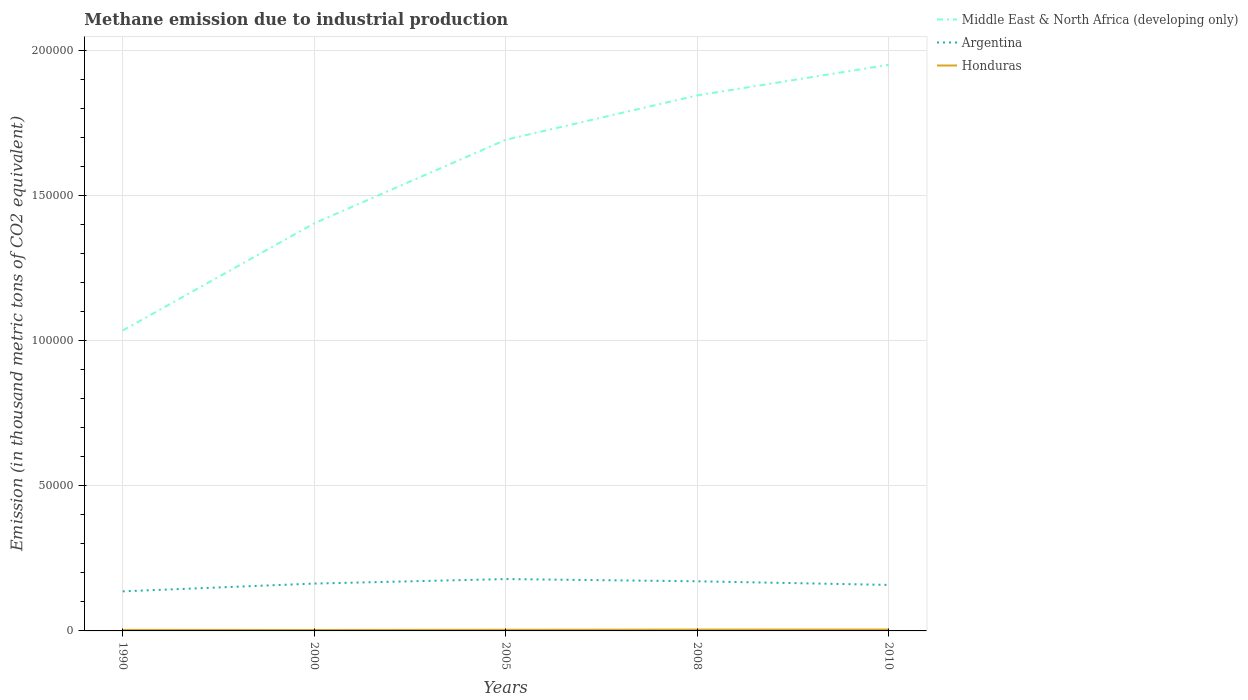Across all years, what is the maximum amount of methane emitted in Middle East & North Africa (developing only)?
Your answer should be very brief. 1.03e+05. What is the total amount of methane emitted in Honduras in the graph?
Provide a short and direct response. -84.9. What is the difference between the highest and the second highest amount of methane emitted in Middle East & North Africa (developing only)?
Offer a terse response. 9.15e+04. What is the difference between the highest and the lowest amount of methane emitted in Middle East & North Africa (developing only)?
Ensure brevity in your answer.  3. Is the amount of methane emitted in Argentina strictly greater than the amount of methane emitted in Honduras over the years?
Make the answer very short. No. What is the difference between two consecutive major ticks on the Y-axis?
Your answer should be very brief. 5.00e+04. Are the values on the major ticks of Y-axis written in scientific E-notation?
Provide a succinct answer. No. Does the graph contain any zero values?
Ensure brevity in your answer.  No. Where does the legend appear in the graph?
Keep it short and to the point. Top right. What is the title of the graph?
Your response must be concise. Methane emission due to industrial production. Does "Togo" appear as one of the legend labels in the graph?
Your answer should be very brief. No. What is the label or title of the X-axis?
Offer a terse response. Years. What is the label or title of the Y-axis?
Your response must be concise. Emission (in thousand metric tons of CO2 equivalent). What is the Emission (in thousand metric tons of CO2 equivalent) of Middle East & North Africa (developing only) in 1990?
Your answer should be compact. 1.03e+05. What is the Emission (in thousand metric tons of CO2 equivalent) of Argentina in 1990?
Provide a succinct answer. 1.36e+04. What is the Emission (in thousand metric tons of CO2 equivalent) of Honduras in 1990?
Offer a very short reply. 349.7. What is the Emission (in thousand metric tons of CO2 equivalent) in Middle East & North Africa (developing only) in 2000?
Give a very brief answer. 1.40e+05. What is the Emission (in thousand metric tons of CO2 equivalent) of Argentina in 2000?
Offer a terse response. 1.63e+04. What is the Emission (in thousand metric tons of CO2 equivalent) of Honduras in 2000?
Ensure brevity in your answer.  315.9. What is the Emission (in thousand metric tons of CO2 equivalent) of Middle East & North Africa (developing only) in 2005?
Give a very brief answer. 1.69e+05. What is the Emission (in thousand metric tons of CO2 equivalent) of Argentina in 2005?
Provide a succinct answer. 1.79e+04. What is the Emission (in thousand metric tons of CO2 equivalent) in Honduras in 2005?
Provide a succinct answer. 393.2. What is the Emission (in thousand metric tons of CO2 equivalent) of Middle East & North Africa (developing only) in 2008?
Offer a terse response. 1.84e+05. What is the Emission (in thousand metric tons of CO2 equivalent) in Argentina in 2008?
Your answer should be very brief. 1.71e+04. What is the Emission (in thousand metric tons of CO2 equivalent) in Honduras in 2008?
Ensure brevity in your answer.  461.7. What is the Emission (in thousand metric tons of CO2 equivalent) of Middle East & North Africa (developing only) in 2010?
Give a very brief answer. 1.95e+05. What is the Emission (in thousand metric tons of CO2 equivalent) of Argentina in 2010?
Make the answer very short. 1.58e+04. What is the Emission (in thousand metric tons of CO2 equivalent) in Honduras in 2010?
Your answer should be compact. 478.1. Across all years, what is the maximum Emission (in thousand metric tons of CO2 equivalent) of Middle East & North Africa (developing only)?
Give a very brief answer. 1.95e+05. Across all years, what is the maximum Emission (in thousand metric tons of CO2 equivalent) of Argentina?
Your answer should be compact. 1.79e+04. Across all years, what is the maximum Emission (in thousand metric tons of CO2 equivalent) of Honduras?
Your answer should be compact. 478.1. Across all years, what is the minimum Emission (in thousand metric tons of CO2 equivalent) of Middle East & North Africa (developing only)?
Offer a terse response. 1.03e+05. Across all years, what is the minimum Emission (in thousand metric tons of CO2 equivalent) in Argentina?
Your answer should be very brief. 1.36e+04. Across all years, what is the minimum Emission (in thousand metric tons of CO2 equivalent) of Honduras?
Your answer should be very brief. 315.9. What is the total Emission (in thousand metric tons of CO2 equivalent) of Middle East & North Africa (developing only) in the graph?
Provide a succinct answer. 7.92e+05. What is the total Emission (in thousand metric tons of CO2 equivalent) of Argentina in the graph?
Ensure brevity in your answer.  8.07e+04. What is the total Emission (in thousand metric tons of CO2 equivalent) of Honduras in the graph?
Your answer should be very brief. 1998.6. What is the difference between the Emission (in thousand metric tons of CO2 equivalent) in Middle East & North Africa (developing only) in 1990 and that in 2000?
Provide a succinct answer. -3.69e+04. What is the difference between the Emission (in thousand metric tons of CO2 equivalent) of Argentina in 1990 and that in 2000?
Give a very brief answer. -2677.8. What is the difference between the Emission (in thousand metric tons of CO2 equivalent) of Honduras in 1990 and that in 2000?
Keep it short and to the point. 33.8. What is the difference between the Emission (in thousand metric tons of CO2 equivalent) of Middle East & North Africa (developing only) in 1990 and that in 2005?
Your answer should be very brief. -6.57e+04. What is the difference between the Emission (in thousand metric tons of CO2 equivalent) in Argentina in 1990 and that in 2005?
Offer a very short reply. -4226.1. What is the difference between the Emission (in thousand metric tons of CO2 equivalent) in Honduras in 1990 and that in 2005?
Offer a very short reply. -43.5. What is the difference between the Emission (in thousand metric tons of CO2 equivalent) in Middle East & North Africa (developing only) in 1990 and that in 2008?
Ensure brevity in your answer.  -8.10e+04. What is the difference between the Emission (in thousand metric tons of CO2 equivalent) in Argentina in 1990 and that in 2008?
Offer a very short reply. -3465. What is the difference between the Emission (in thousand metric tons of CO2 equivalent) of Honduras in 1990 and that in 2008?
Ensure brevity in your answer.  -112. What is the difference between the Emission (in thousand metric tons of CO2 equivalent) of Middle East & North Africa (developing only) in 1990 and that in 2010?
Give a very brief answer. -9.15e+04. What is the difference between the Emission (in thousand metric tons of CO2 equivalent) in Argentina in 1990 and that in 2010?
Your response must be concise. -2215.6. What is the difference between the Emission (in thousand metric tons of CO2 equivalent) in Honduras in 1990 and that in 2010?
Give a very brief answer. -128.4. What is the difference between the Emission (in thousand metric tons of CO2 equivalent) of Middle East & North Africa (developing only) in 2000 and that in 2005?
Your answer should be very brief. -2.88e+04. What is the difference between the Emission (in thousand metric tons of CO2 equivalent) of Argentina in 2000 and that in 2005?
Ensure brevity in your answer.  -1548.3. What is the difference between the Emission (in thousand metric tons of CO2 equivalent) in Honduras in 2000 and that in 2005?
Your response must be concise. -77.3. What is the difference between the Emission (in thousand metric tons of CO2 equivalent) of Middle East & North Africa (developing only) in 2000 and that in 2008?
Your response must be concise. -4.41e+04. What is the difference between the Emission (in thousand metric tons of CO2 equivalent) of Argentina in 2000 and that in 2008?
Your answer should be very brief. -787.2. What is the difference between the Emission (in thousand metric tons of CO2 equivalent) in Honduras in 2000 and that in 2008?
Give a very brief answer. -145.8. What is the difference between the Emission (in thousand metric tons of CO2 equivalent) of Middle East & North Africa (developing only) in 2000 and that in 2010?
Provide a succinct answer. -5.46e+04. What is the difference between the Emission (in thousand metric tons of CO2 equivalent) in Argentina in 2000 and that in 2010?
Keep it short and to the point. 462.2. What is the difference between the Emission (in thousand metric tons of CO2 equivalent) in Honduras in 2000 and that in 2010?
Keep it short and to the point. -162.2. What is the difference between the Emission (in thousand metric tons of CO2 equivalent) of Middle East & North Africa (developing only) in 2005 and that in 2008?
Provide a short and direct response. -1.53e+04. What is the difference between the Emission (in thousand metric tons of CO2 equivalent) of Argentina in 2005 and that in 2008?
Your answer should be compact. 761.1. What is the difference between the Emission (in thousand metric tons of CO2 equivalent) in Honduras in 2005 and that in 2008?
Give a very brief answer. -68.5. What is the difference between the Emission (in thousand metric tons of CO2 equivalent) in Middle East & North Africa (developing only) in 2005 and that in 2010?
Give a very brief answer. -2.58e+04. What is the difference between the Emission (in thousand metric tons of CO2 equivalent) of Argentina in 2005 and that in 2010?
Your answer should be very brief. 2010.5. What is the difference between the Emission (in thousand metric tons of CO2 equivalent) of Honduras in 2005 and that in 2010?
Provide a short and direct response. -84.9. What is the difference between the Emission (in thousand metric tons of CO2 equivalent) of Middle East & North Africa (developing only) in 2008 and that in 2010?
Offer a terse response. -1.05e+04. What is the difference between the Emission (in thousand metric tons of CO2 equivalent) of Argentina in 2008 and that in 2010?
Provide a short and direct response. 1249.4. What is the difference between the Emission (in thousand metric tons of CO2 equivalent) of Honduras in 2008 and that in 2010?
Make the answer very short. -16.4. What is the difference between the Emission (in thousand metric tons of CO2 equivalent) of Middle East & North Africa (developing only) in 1990 and the Emission (in thousand metric tons of CO2 equivalent) of Argentina in 2000?
Offer a very short reply. 8.71e+04. What is the difference between the Emission (in thousand metric tons of CO2 equivalent) of Middle East & North Africa (developing only) in 1990 and the Emission (in thousand metric tons of CO2 equivalent) of Honduras in 2000?
Give a very brief answer. 1.03e+05. What is the difference between the Emission (in thousand metric tons of CO2 equivalent) of Argentina in 1990 and the Emission (in thousand metric tons of CO2 equivalent) of Honduras in 2000?
Ensure brevity in your answer.  1.33e+04. What is the difference between the Emission (in thousand metric tons of CO2 equivalent) of Middle East & North Africa (developing only) in 1990 and the Emission (in thousand metric tons of CO2 equivalent) of Argentina in 2005?
Provide a succinct answer. 8.56e+04. What is the difference between the Emission (in thousand metric tons of CO2 equivalent) in Middle East & North Africa (developing only) in 1990 and the Emission (in thousand metric tons of CO2 equivalent) in Honduras in 2005?
Ensure brevity in your answer.  1.03e+05. What is the difference between the Emission (in thousand metric tons of CO2 equivalent) in Argentina in 1990 and the Emission (in thousand metric tons of CO2 equivalent) in Honduras in 2005?
Your answer should be very brief. 1.32e+04. What is the difference between the Emission (in thousand metric tons of CO2 equivalent) of Middle East & North Africa (developing only) in 1990 and the Emission (in thousand metric tons of CO2 equivalent) of Argentina in 2008?
Provide a short and direct response. 8.63e+04. What is the difference between the Emission (in thousand metric tons of CO2 equivalent) of Middle East & North Africa (developing only) in 1990 and the Emission (in thousand metric tons of CO2 equivalent) of Honduras in 2008?
Provide a succinct answer. 1.03e+05. What is the difference between the Emission (in thousand metric tons of CO2 equivalent) in Argentina in 1990 and the Emission (in thousand metric tons of CO2 equivalent) in Honduras in 2008?
Provide a succinct answer. 1.32e+04. What is the difference between the Emission (in thousand metric tons of CO2 equivalent) of Middle East & North Africa (developing only) in 1990 and the Emission (in thousand metric tons of CO2 equivalent) of Argentina in 2010?
Your answer should be compact. 8.76e+04. What is the difference between the Emission (in thousand metric tons of CO2 equivalent) in Middle East & North Africa (developing only) in 1990 and the Emission (in thousand metric tons of CO2 equivalent) in Honduras in 2010?
Your response must be concise. 1.03e+05. What is the difference between the Emission (in thousand metric tons of CO2 equivalent) in Argentina in 1990 and the Emission (in thousand metric tons of CO2 equivalent) in Honduras in 2010?
Offer a very short reply. 1.31e+04. What is the difference between the Emission (in thousand metric tons of CO2 equivalent) in Middle East & North Africa (developing only) in 2000 and the Emission (in thousand metric tons of CO2 equivalent) in Argentina in 2005?
Your answer should be very brief. 1.22e+05. What is the difference between the Emission (in thousand metric tons of CO2 equivalent) of Middle East & North Africa (developing only) in 2000 and the Emission (in thousand metric tons of CO2 equivalent) of Honduras in 2005?
Give a very brief answer. 1.40e+05. What is the difference between the Emission (in thousand metric tons of CO2 equivalent) of Argentina in 2000 and the Emission (in thousand metric tons of CO2 equivalent) of Honduras in 2005?
Give a very brief answer. 1.59e+04. What is the difference between the Emission (in thousand metric tons of CO2 equivalent) of Middle East & North Africa (developing only) in 2000 and the Emission (in thousand metric tons of CO2 equivalent) of Argentina in 2008?
Your answer should be very brief. 1.23e+05. What is the difference between the Emission (in thousand metric tons of CO2 equivalent) in Middle East & North Africa (developing only) in 2000 and the Emission (in thousand metric tons of CO2 equivalent) in Honduras in 2008?
Ensure brevity in your answer.  1.40e+05. What is the difference between the Emission (in thousand metric tons of CO2 equivalent) of Argentina in 2000 and the Emission (in thousand metric tons of CO2 equivalent) of Honduras in 2008?
Ensure brevity in your answer.  1.58e+04. What is the difference between the Emission (in thousand metric tons of CO2 equivalent) of Middle East & North Africa (developing only) in 2000 and the Emission (in thousand metric tons of CO2 equivalent) of Argentina in 2010?
Keep it short and to the point. 1.24e+05. What is the difference between the Emission (in thousand metric tons of CO2 equivalent) in Middle East & North Africa (developing only) in 2000 and the Emission (in thousand metric tons of CO2 equivalent) in Honduras in 2010?
Give a very brief answer. 1.40e+05. What is the difference between the Emission (in thousand metric tons of CO2 equivalent) in Argentina in 2000 and the Emission (in thousand metric tons of CO2 equivalent) in Honduras in 2010?
Your answer should be compact. 1.58e+04. What is the difference between the Emission (in thousand metric tons of CO2 equivalent) in Middle East & North Africa (developing only) in 2005 and the Emission (in thousand metric tons of CO2 equivalent) in Argentina in 2008?
Your answer should be compact. 1.52e+05. What is the difference between the Emission (in thousand metric tons of CO2 equivalent) in Middle East & North Africa (developing only) in 2005 and the Emission (in thousand metric tons of CO2 equivalent) in Honduras in 2008?
Your answer should be very brief. 1.69e+05. What is the difference between the Emission (in thousand metric tons of CO2 equivalent) in Argentina in 2005 and the Emission (in thousand metric tons of CO2 equivalent) in Honduras in 2008?
Give a very brief answer. 1.74e+04. What is the difference between the Emission (in thousand metric tons of CO2 equivalent) in Middle East & North Africa (developing only) in 2005 and the Emission (in thousand metric tons of CO2 equivalent) in Argentina in 2010?
Offer a very short reply. 1.53e+05. What is the difference between the Emission (in thousand metric tons of CO2 equivalent) of Middle East & North Africa (developing only) in 2005 and the Emission (in thousand metric tons of CO2 equivalent) of Honduras in 2010?
Your answer should be compact. 1.69e+05. What is the difference between the Emission (in thousand metric tons of CO2 equivalent) in Argentina in 2005 and the Emission (in thousand metric tons of CO2 equivalent) in Honduras in 2010?
Keep it short and to the point. 1.74e+04. What is the difference between the Emission (in thousand metric tons of CO2 equivalent) of Middle East & North Africa (developing only) in 2008 and the Emission (in thousand metric tons of CO2 equivalent) of Argentina in 2010?
Your answer should be very brief. 1.69e+05. What is the difference between the Emission (in thousand metric tons of CO2 equivalent) of Middle East & North Africa (developing only) in 2008 and the Emission (in thousand metric tons of CO2 equivalent) of Honduras in 2010?
Offer a very short reply. 1.84e+05. What is the difference between the Emission (in thousand metric tons of CO2 equivalent) of Argentina in 2008 and the Emission (in thousand metric tons of CO2 equivalent) of Honduras in 2010?
Provide a succinct answer. 1.66e+04. What is the average Emission (in thousand metric tons of CO2 equivalent) in Middle East & North Africa (developing only) per year?
Your answer should be very brief. 1.58e+05. What is the average Emission (in thousand metric tons of CO2 equivalent) in Argentina per year?
Give a very brief answer. 1.61e+04. What is the average Emission (in thousand metric tons of CO2 equivalent) of Honduras per year?
Offer a terse response. 399.72. In the year 1990, what is the difference between the Emission (in thousand metric tons of CO2 equivalent) of Middle East & North Africa (developing only) and Emission (in thousand metric tons of CO2 equivalent) of Argentina?
Provide a short and direct response. 8.98e+04. In the year 1990, what is the difference between the Emission (in thousand metric tons of CO2 equivalent) of Middle East & North Africa (developing only) and Emission (in thousand metric tons of CO2 equivalent) of Honduras?
Your response must be concise. 1.03e+05. In the year 1990, what is the difference between the Emission (in thousand metric tons of CO2 equivalent) of Argentina and Emission (in thousand metric tons of CO2 equivalent) of Honduras?
Ensure brevity in your answer.  1.33e+04. In the year 2000, what is the difference between the Emission (in thousand metric tons of CO2 equivalent) in Middle East & North Africa (developing only) and Emission (in thousand metric tons of CO2 equivalent) in Argentina?
Give a very brief answer. 1.24e+05. In the year 2000, what is the difference between the Emission (in thousand metric tons of CO2 equivalent) in Middle East & North Africa (developing only) and Emission (in thousand metric tons of CO2 equivalent) in Honduras?
Keep it short and to the point. 1.40e+05. In the year 2000, what is the difference between the Emission (in thousand metric tons of CO2 equivalent) of Argentina and Emission (in thousand metric tons of CO2 equivalent) of Honduras?
Your answer should be very brief. 1.60e+04. In the year 2005, what is the difference between the Emission (in thousand metric tons of CO2 equivalent) of Middle East & North Africa (developing only) and Emission (in thousand metric tons of CO2 equivalent) of Argentina?
Offer a terse response. 1.51e+05. In the year 2005, what is the difference between the Emission (in thousand metric tons of CO2 equivalent) in Middle East & North Africa (developing only) and Emission (in thousand metric tons of CO2 equivalent) in Honduras?
Your response must be concise. 1.69e+05. In the year 2005, what is the difference between the Emission (in thousand metric tons of CO2 equivalent) of Argentina and Emission (in thousand metric tons of CO2 equivalent) of Honduras?
Ensure brevity in your answer.  1.75e+04. In the year 2008, what is the difference between the Emission (in thousand metric tons of CO2 equivalent) of Middle East & North Africa (developing only) and Emission (in thousand metric tons of CO2 equivalent) of Argentina?
Your answer should be very brief. 1.67e+05. In the year 2008, what is the difference between the Emission (in thousand metric tons of CO2 equivalent) of Middle East & North Africa (developing only) and Emission (in thousand metric tons of CO2 equivalent) of Honduras?
Your answer should be compact. 1.84e+05. In the year 2008, what is the difference between the Emission (in thousand metric tons of CO2 equivalent) in Argentina and Emission (in thousand metric tons of CO2 equivalent) in Honduras?
Keep it short and to the point. 1.66e+04. In the year 2010, what is the difference between the Emission (in thousand metric tons of CO2 equivalent) in Middle East & North Africa (developing only) and Emission (in thousand metric tons of CO2 equivalent) in Argentina?
Keep it short and to the point. 1.79e+05. In the year 2010, what is the difference between the Emission (in thousand metric tons of CO2 equivalent) in Middle East & North Africa (developing only) and Emission (in thousand metric tons of CO2 equivalent) in Honduras?
Keep it short and to the point. 1.94e+05. In the year 2010, what is the difference between the Emission (in thousand metric tons of CO2 equivalent) in Argentina and Emission (in thousand metric tons of CO2 equivalent) in Honduras?
Your response must be concise. 1.54e+04. What is the ratio of the Emission (in thousand metric tons of CO2 equivalent) in Middle East & North Africa (developing only) in 1990 to that in 2000?
Offer a terse response. 0.74. What is the ratio of the Emission (in thousand metric tons of CO2 equivalent) in Argentina in 1990 to that in 2000?
Ensure brevity in your answer.  0.84. What is the ratio of the Emission (in thousand metric tons of CO2 equivalent) of Honduras in 1990 to that in 2000?
Offer a very short reply. 1.11. What is the ratio of the Emission (in thousand metric tons of CO2 equivalent) in Middle East & North Africa (developing only) in 1990 to that in 2005?
Keep it short and to the point. 0.61. What is the ratio of the Emission (in thousand metric tons of CO2 equivalent) of Argentina in 1990 to that in 2005?
Make the answer very short. 0.76. What is the ratio of the Emission (in thousand metric tons of CO2 equivalent) in Honduras in 1990 to that in 2005?
Your response must be concise. 0.89. What is the ratio of the Emission (in thousand metric tons of CO2 equivalent) of Middle East & North Africa (developing only) in 1990 to that in 2008?
Provide a short and direct response. 0.56. What is the ratio of the Emission (in thousand metric tons of CO2 equivalent) of Argentina in 1990 to that in 2008?
Give a very brief answer. 0.8. What is the ratio of the Emission (in thousand metric tons of CO2 equivalent) of Honduras in 1990 to that in 2008?
Your response must be concise. 0.76. What is the ratio of the Emission (in thousand metric tons of CO2 equivalent) of Middle East & North Africa (developing only) in 1990 to that in 2010?
Your response must be concise. 0.53. What is the ratio of the Emission (in thousand metric tons of CO2 equivalent) of Argentina in 1990 to that in 2010?
Offer a very short reply. 0.86. What is the ratio of the Emission (in thousand metric tons of CO2 equivalent) of Honduras in 1990 to that in 2010?
Your answer should be compact. 0.73. What is the ratio of the Emission (in thousand metric tons of CO2 equivalent) of Middle East & North Africa (developing only) in 2000 to that in 2005?
Offer a very short reply. 0.83. What is the ratio of the Emission (in thousand metric tons of CO2 equivalent) of Argentina in 2000 to that in 2005?
Your answer should be compact. 0.91. What is the ratio of the Emission (in thousand metric tons of CO2 equivalent) in Honduras in 2000 to that in 2005?
Offer a very short reply. 0.8. What is the ratio of the Emission (in thousand metric tons of CO2 equivalent) of Middle East & North Africa (developing only) in 2000 to that in 2008?
Your answer should be compact. 0.76. What is the ratio of the Emission (in thousand metric tons of CO2 equivalent) in Argentina in 2000 to that in 2008?
Your answer should be very brief. 0.95. What is the ratio of the Emission (in thousand metric tons of CO2 equivalent) in Honduras in 2000 to that in 2008?
Ensure brevity in your answer.  0.68. What is the ratio of the Emission (in thousand metric tons of CO2 equivalent) in Middle East & North Africa (developing only) in 2000 to that in 2010?
Keep it short and to the point. 0.72. What is the ratio of the Emission (in thousand metric tons of CO2 equivalent) in Argentina in 2000 to that in 2010?
Give a very brief answer. 1.03. What is the ratio of the Emission (in thousand metric tons of CO2 equivalent) in Honduras in 2000 to that in 2010?
Ensure brevity in your answer.  0.66. What is the ratio of the Emission (in thousand metric tons of CO2 equivalent) of Middle East & North Africa (developing only) in 2005 to that in 2008?
Make the answer very short. 0.92. What is the ratio of the Emission (in thousand metric tons of CO2 equivalent) in Argentina in 2005 to that in 2008?
Offer a very short reply. 1.04. What is the ratio of the Emission (in thousand metric tons of CO2 equivalent) of Honduras in 2005 to that in 2008?
Keep it short and to the point. 0.85. What is the ratio of the Emission (in thousand metric tons of CO2 equivalent) of Middle East & North Africa (developing only) in 2005 to that in 2010?
Provide a succinct answer. 0.87. What is the ratio of the Emission (in thousand metric tons of CO2 equivalent) of Argentina in 2005 to that in 2010?
Provide a short and direct response. 1.13. What is the ratio of the Emission (in thousand metric tons of CO2 equivalent) of Honduras in 2005 to that in 2010?
Your response must be concise. 0.82. What is the ratio of the Emission (in thousand metric tons of CO2 equivalent) of Middle East & North Africa (developing only) in 2008 to that in 2010?
Keep it short and to the point. 0.95. What is the ratio of the Emission (in thousand metric tons of CO2 equivalent) in Argentina in 2008 to that in 2010?
Your response must be concise. 1.08. What is the ratio of the Emission (in thousand metric tons of CO2 equivalent) in Honduras in 2008 to that in 2010?
Make the answer very short. 0.97. What is the difference between the highest and the second highest Emission (in thousand metric tons of CO2 equivalent) in Middle East & North Africa (developing only)?
Your response must be concise. 1.05e+04. What is the difference between the highest and the second highest Emission (in thousand metric tons of CO2 equivalent) of Argentina?
Your response must be concise. 761.1. What is the difference between the highest and the second highest Emission (in thousand metric tons of CO2 equivalent) of Honduras?
Offer a very short reply. 16.4. What is the difference between the highest and the lowest Emission (in thousand metric tons of CO2 equivalent) in Middle East & North Africa (developing only)?
Offer a very short reply. 9.15e+04. What is the difference between the highest and the lowest Emission (in thousand metric tons of CO2 equivalent) in Argentina?
Offer a very short reply. 4226.1. What is the difference between the highest and the lowest Emission (in thousand metric tons of CO2 equivalent) of Honduras?
Your answer should be very brief. 162.2. 